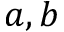Convert formula to latex. <formula><loc_0><loc_0><loc_500><loc_500>a , b</formula> 